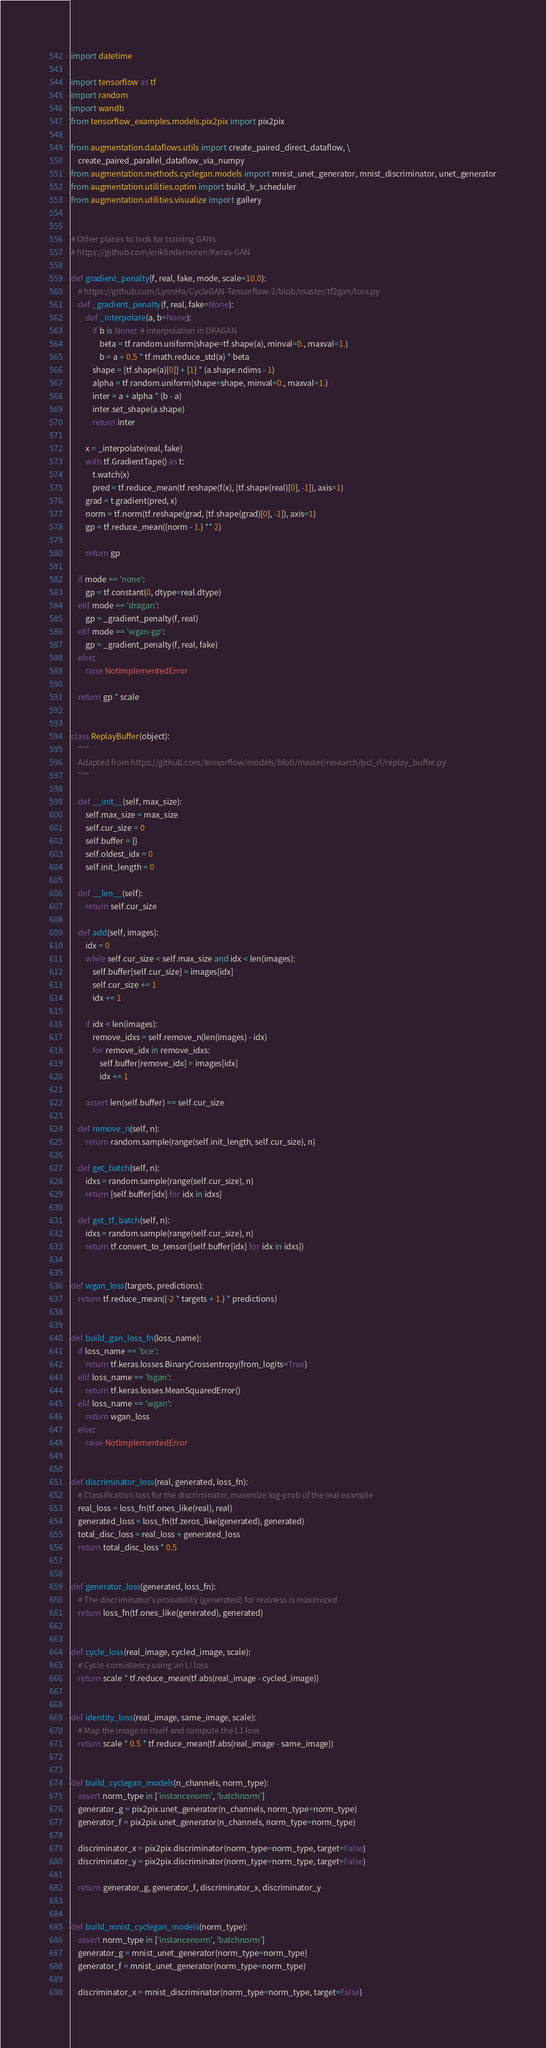<code> <loc_0><loc_0><loc_500><loc_500><_Python_>import datetime

import tensorflow as tf
import random
import wandb
from tensorflow_examples.models.pix2pix import pix2pix

from augmentation.dataflows.utils import create_paired_direct_dataflow, \
    create_paired_parallel_dataflow_via_numpy
from augmentation.methods.cyclegan.models import mnist_unet_generator, mnist_discriminator, unet_generator
from augmentation.utilities.optim import build_lr_scheduler
from augmentation.utilities.visualize import gallery


# Other places to look for training GANs
# https://github.com/eriklindernoren/Keras-GAN

def gradient_penalty(f, real, fake, mode, scale=10.0):
    # https://github.com/LynnHo/CycleGAN-Tensorflow-2/blob/master/tf2gan/loss.py
    def _gradient_penalty(f, real, fake=None):
        def _interpolate(a, b=None):
            if b is None:  # interpolation in DRAGAN
                beta = tf.random.uniform(shape=tf.shape(a), minval=0., maxval=1.)
                b = a + 0.5 * tf.math.reduce_std(a) * beta
            shape = [tf.shape(a)[0]] + [1] * (a.shape.ndims - 1)
            alpha = tf.random.uniform(shape=shape, minval=0., maxval=1.)
            inter = a + alpha * (b - a)
            inter.set_shape(a.shape)
            return inter

        x = _interpolate(real, fake)
        with tf.GradientTape() as t:
            t.watch(x)
            pred = tf.reduce_mean(tf.reshape(f(x), [tf.shape(real)[0], -1]), axis=1)
        grad = t.gradient(pred, x)
        norm = tf.norm(tf.reshape(grad, [tf.shape(grad)[0], -1]), axis=1)
        gp = tf.reduce_mean((norm - 1.) ** 2)

        return gp

    if mode == 'none':
        gp = tf.constant(0, dtype=real.dtype)
    elif mode == 'dragan':
        gp = _gradient_penalty(f, real)
    elif mode == 'wgan-gp':
        gp = _gradient_penalty(f, real, fake)
    else:
        raise NotImplementedError

    return gp * scale


class ReplayBuffer(object):
    """
    Adapted from https://github.com/tensorflow/models/blob/master/research/pcl_rl/replay_buffer.py
    """

    def __init__(self, max_size):
        self.max_size = max_size
        self.cur_size = 0
        self.buffer = {}
        self.oldest_idx = 0
        self.init_length = 0

    def __len__(self):
        return self.cur_size

    def add(self, images):
        idx = 0
        while self.cur_size < self.max_size and idx < len(images):
            self.buffer[self.cur_size] = images[idx]
            self.cur_size += 1
            idx += 1

        if idx < len(images):
            remove_idxs = self.remove_n(len(images) - idx)
            for remove_idx in remove_idxs:
                self.buffer[remove_idx] = images[idx]
                idx += 1

        assert len(self.buffer) == self.cur_size

    def remove_n(self, n):
        return random.sample(range(self.init_length, self.cur_size), n)

    def get_batch(self, n):
        idxs = random.sample(range(self.cur_size), n)
        return [self.buffer[idx] for idx in idxs]

    def get_tf_batch(self, n):
        idxs = random.sample(range(self.cur_size), n)
        return tf.convert_to_tensor([self.buffer[idx] for idx in idxs])


def wgan_loss(targets, predictions):
    return tf.reduce_mean((-2 * targets + 1.) * predictions)


def build_gan_loss_fn(loss_name):
    if loss_name == 'bce':
        return tf.keras.losses.BinaryCrossentropy(from_logits=True)
    elif loss_name == 'lsgan':
        return tf.keras.losses.MeanSquaredError()
    elif loss_name == 'wgan':
        return wgan_loss
    else:
        raise NotImplementedError


def discriminator_loss(real, generated, loss_fn):
    # Classification loss for the discriminator, maximize log-prob of the real example
    real_loss = loss_fn(tf.ones_like(real), real)
    generated_loss = loss_fn(tf.zeros_like(generated), generated)
    total_disc_loss = real_loss + generated_loss
    return total_disc_loss * 0.5


def generator_loss(generated, loss_fn):
    # The discriminator's probability (generated) for realness is maximized
    return loss_fn(tf.ones_like(generated), generated)


def cycle_loss(real_image, cycled_image, scale):
    # Cycle-consistency using an L! loss
    return scale * tf.reduce_mean(tf.abs(real_image - cycled_image))


def identity_loss(real_image, same_image, scale):
    # Map the image to itself and compute the L1 loss
    return scale * 0.5 * tf.reduce_mean(tf.abs(real_image - same_image))


def build_cyclegan_models(n_channels, norm_type):
    assert norm_type in ['instancenorm', 'batchnorm']
    generator_g = pix2pix.unet_generator(n_channels, norm_type=norm_type)
    generator_f = pix2pix.unet_generator(n_channels, norm_type=norm_type)

    discriminator_x = pix2pix.discriminator(norm_type=norm_type, target=False)
    discriminator_y = pix2pix.discriminator(norm_type=norm_type, target=False)

    return generator_g, generator_f, discriminator_x, discriminator_y


def build_mnist_cyclegan_models(norm_type):
    assert norm_type in ['instancenorm', 'batchnorm']
    generator_g = mnist_unet_generator(norm_type=norm_type)
    generator_f = mnist_unet_generator(norm_type=norm_type)

    discriminator_x = mnist_discriminator(norm_type=norm_type, target=False)</code> 